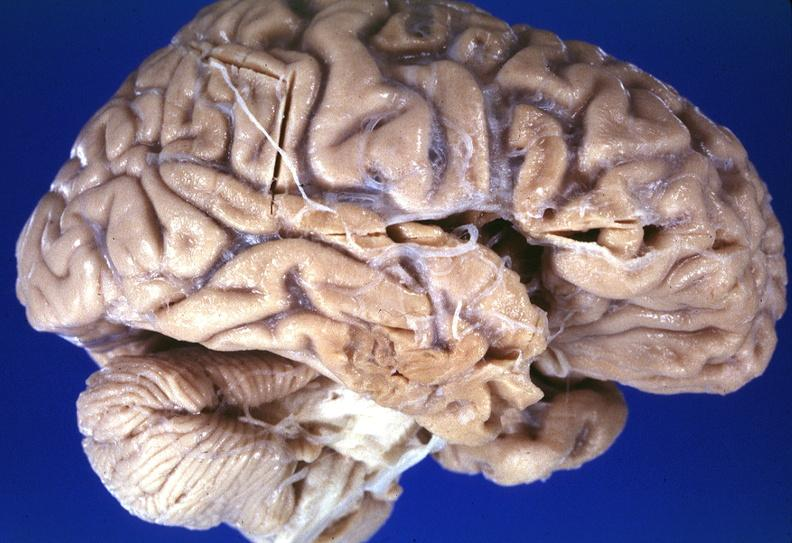s lesion in dome of uterus present?
Answer the question using a single word or phrase. No 